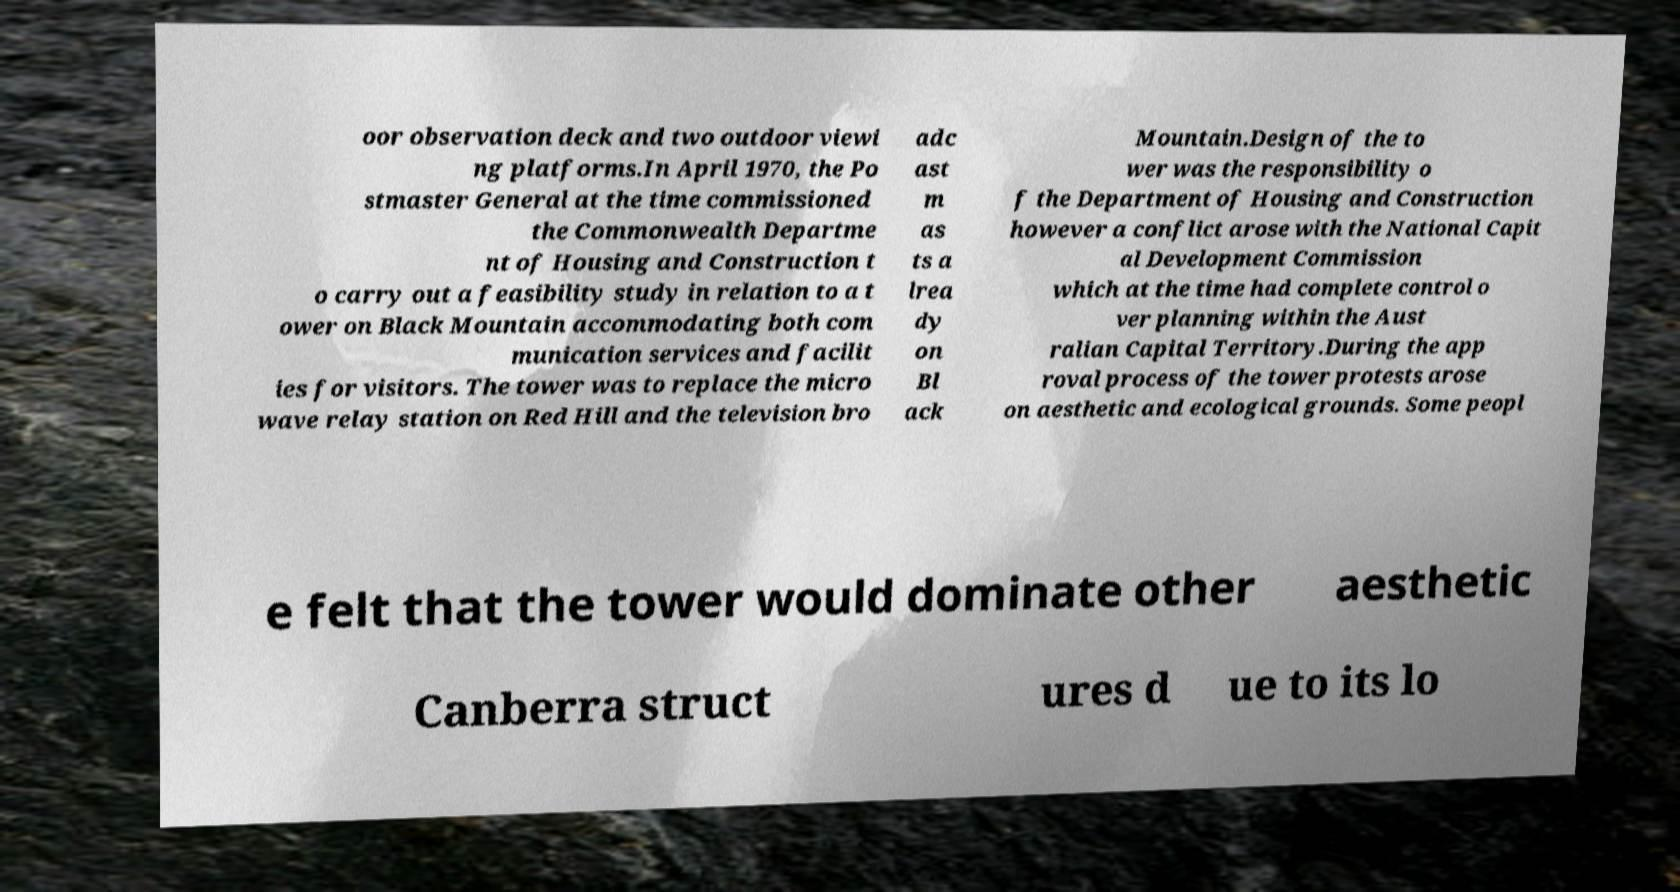What messages or text are displayed in this image? I need them in a readable, typed format. oor observation deck and two outdoor viewi ng platforms.In April 1970, the Po stmaster General at the time commissioned the Commonwealth Departme nt of Housing and Construction t o carry out a feasibility study in relation to a t ower on Black Mountain accommodating both com munication services and facilit ies for visitors. The tower was to replace the micro wave relay station on Red Hill and the television bro adc ast m as ts a lrea dy on Bl ack Mountain.Design of the to wer was the responsibility o f the Department of Housing and Construction however a conflict arose with the National Capit al Development Commission which at the time had complete control o ver planning within the Aust ralian Capital Territory.During the app roval process of the tower protests arose on aesthetic and ecological grounds. Some peopl e felt that the tower would dominate other aesthetic Canberra struct ures d ue to its lo 